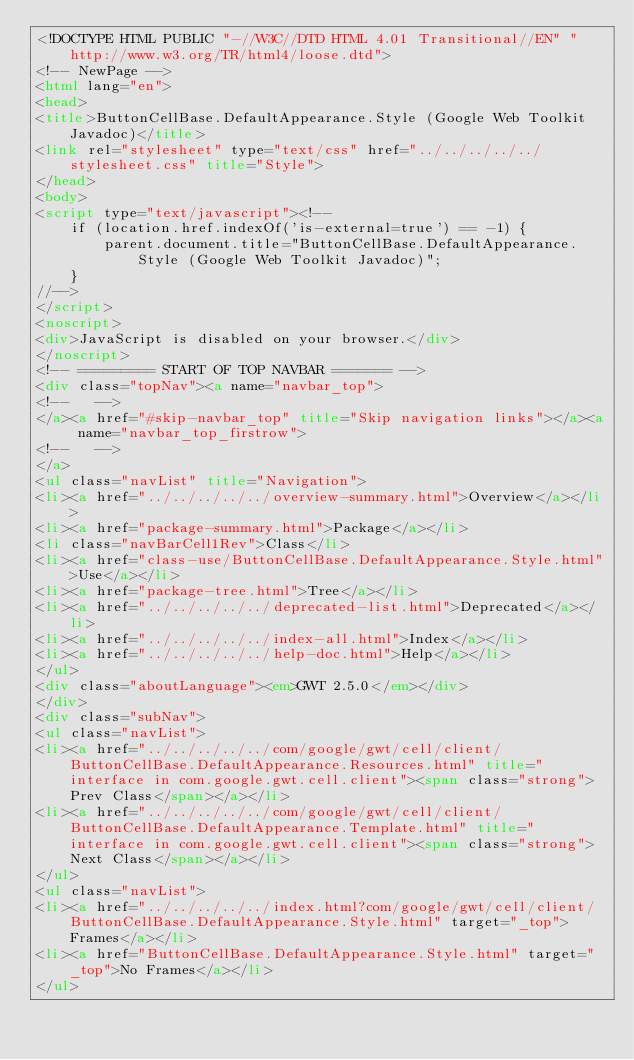Convert code to text. <code><loc_0><loc_0><loc_500><loc_500><_HTML_><!DOCTYPE HTML PUBLIC "-//W3C//DTD HTML 4.01 Transitional//EN" "http://www.w3.org/TR/html4/loose.dtd">
<!-- NewPage -->
<html lang="en">
<head>
<title>ButtonCellBase.DefaultAppearance.Style (Google Web Toolkit Javadoc)</title>
<link rel="stylesheet" type="text/css" href="../../../../../stylesheet.css" title="Style">
</head>
<body>
<script type="text/javascript"><!--
    if (location.href.indexOf('is-external=true') == -1) {
        parent.document.title="ButtonCellBase.DefaultAppearance.Style (Google Web Toolkit Javadoc)";
    }
//-->
</script>
<noscript>
<div>JavaScript is disabled on your browser.</div>
</noscript>
<!-- ========= START OF TOP NAVBAR ======= -->
<div class="topNav"><a name="navbar_top">
<!--   -->
</a><a href="#skip-navbar_top" title="Skip navigation links"></a><a name="navbar_top_firstrow">
<!--   -->
</a>
<ul class="navList" title="Navigation">
<li><a href="../../../../../overview-summary.html">Overview</a></li>
<li><a href="package-summary.html">Package</a></li>
<li class="navBarCell1Rev">Class</li>
<li><a href="class-use/ButtonCellBase.DefaultAppearance.Style.html">Use</a></li>
<li><a href="package-tree.html">Tree</a></li>
<li><a href="../../../../../deprecated-list.html">Deprecated</a></li>
<li><a href="../../../../../index-all.html">Index</a></li>
<li><a href="../../../../../help-doc.html">Help</a></li>
</ul>
<div class="aboutLanguage"><em>GWT 2.5.0</em></div>
</div>
<div class="subNav">
<ul class="navList">
<li><a href="../../../../../com/google/gwt/cell/client/ButtonCellBase.DefaultAppearance.Resources.html" title="interface in com.google.gwt.cell.client"><span class="strong">Prev Class</span></a></li>
<li><a href="../../../../../com/google/gwt/cell/client/ButtonCellBase.DefaultAppearance.Template.html" title="interface in com.google.gwt.cell.client"><span class="strong">Next Class</span></a></li>
</ul>
<ul class="navList">
<li><a href="../../../../../index.html?com/google/gwt/cell/client/ButtonCellBase.DefaultAppearance.Style.html" target="_top">Frames</a></li>
<li><a href="ButtonCellBase.DefaultAppearance.Style.html" target="_top">No Frames</a></li>
</ul></code> 